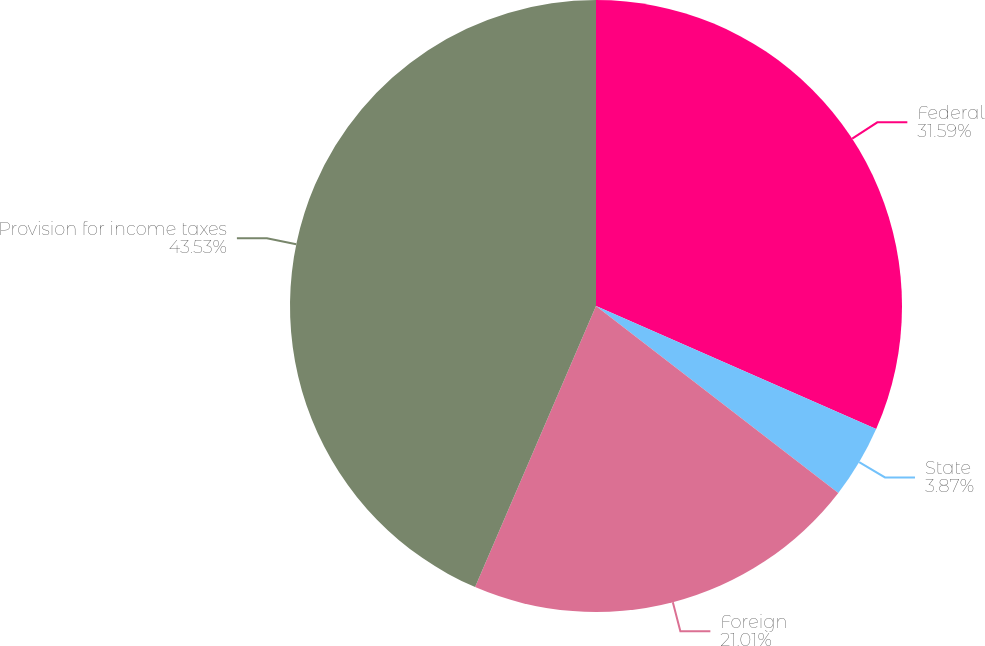Convert chart to OTSL. <chart><loc_0><loc_0><loc_500><loc_500><pie_chart><fcel>Federal<fcel>State<fcel>Foreign<fcel>Provision for income taxes<nl><fcel>31.59%<fcel>3.87%<fcel>21.01%<fcel>43.54%<nl></chart> 